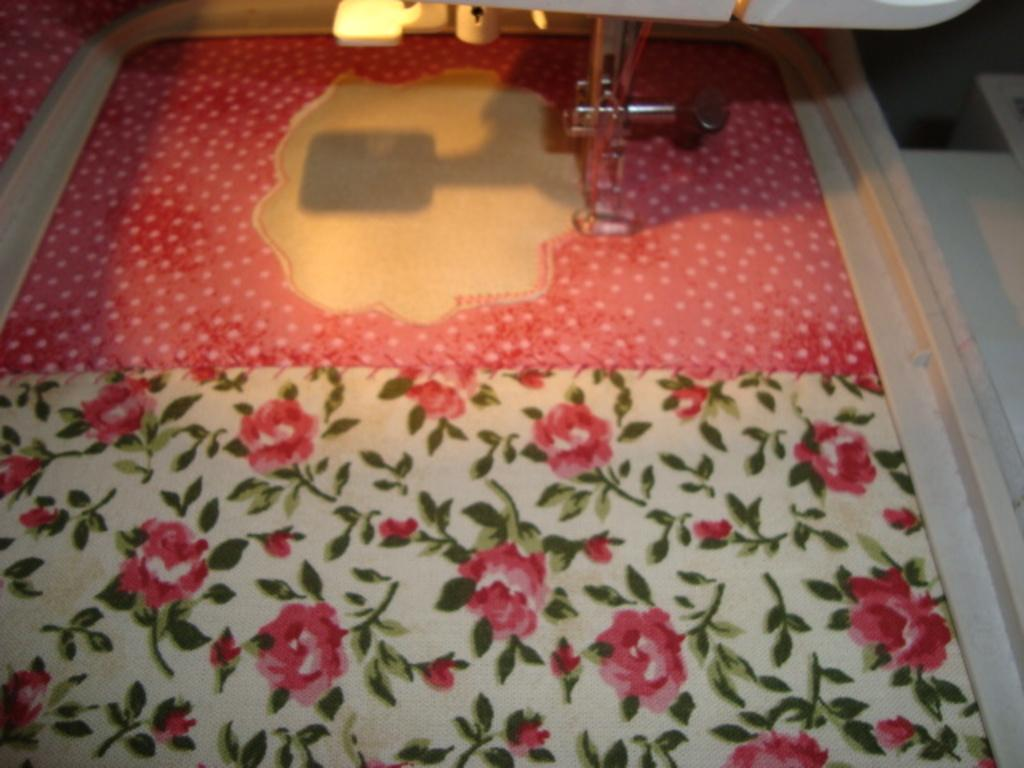What is the primary object in the image? There is a stitching machine in the image. What else can be seen in the image? There is a cloth in the image. How many pins are used to hold the vest in the image? There is no vest present in the image, and therefore no pins can be observed holding it. What type of smile can be seen on the cloth in the image? There is no smile present in the image, as it features a stitching machine and a cloth. 